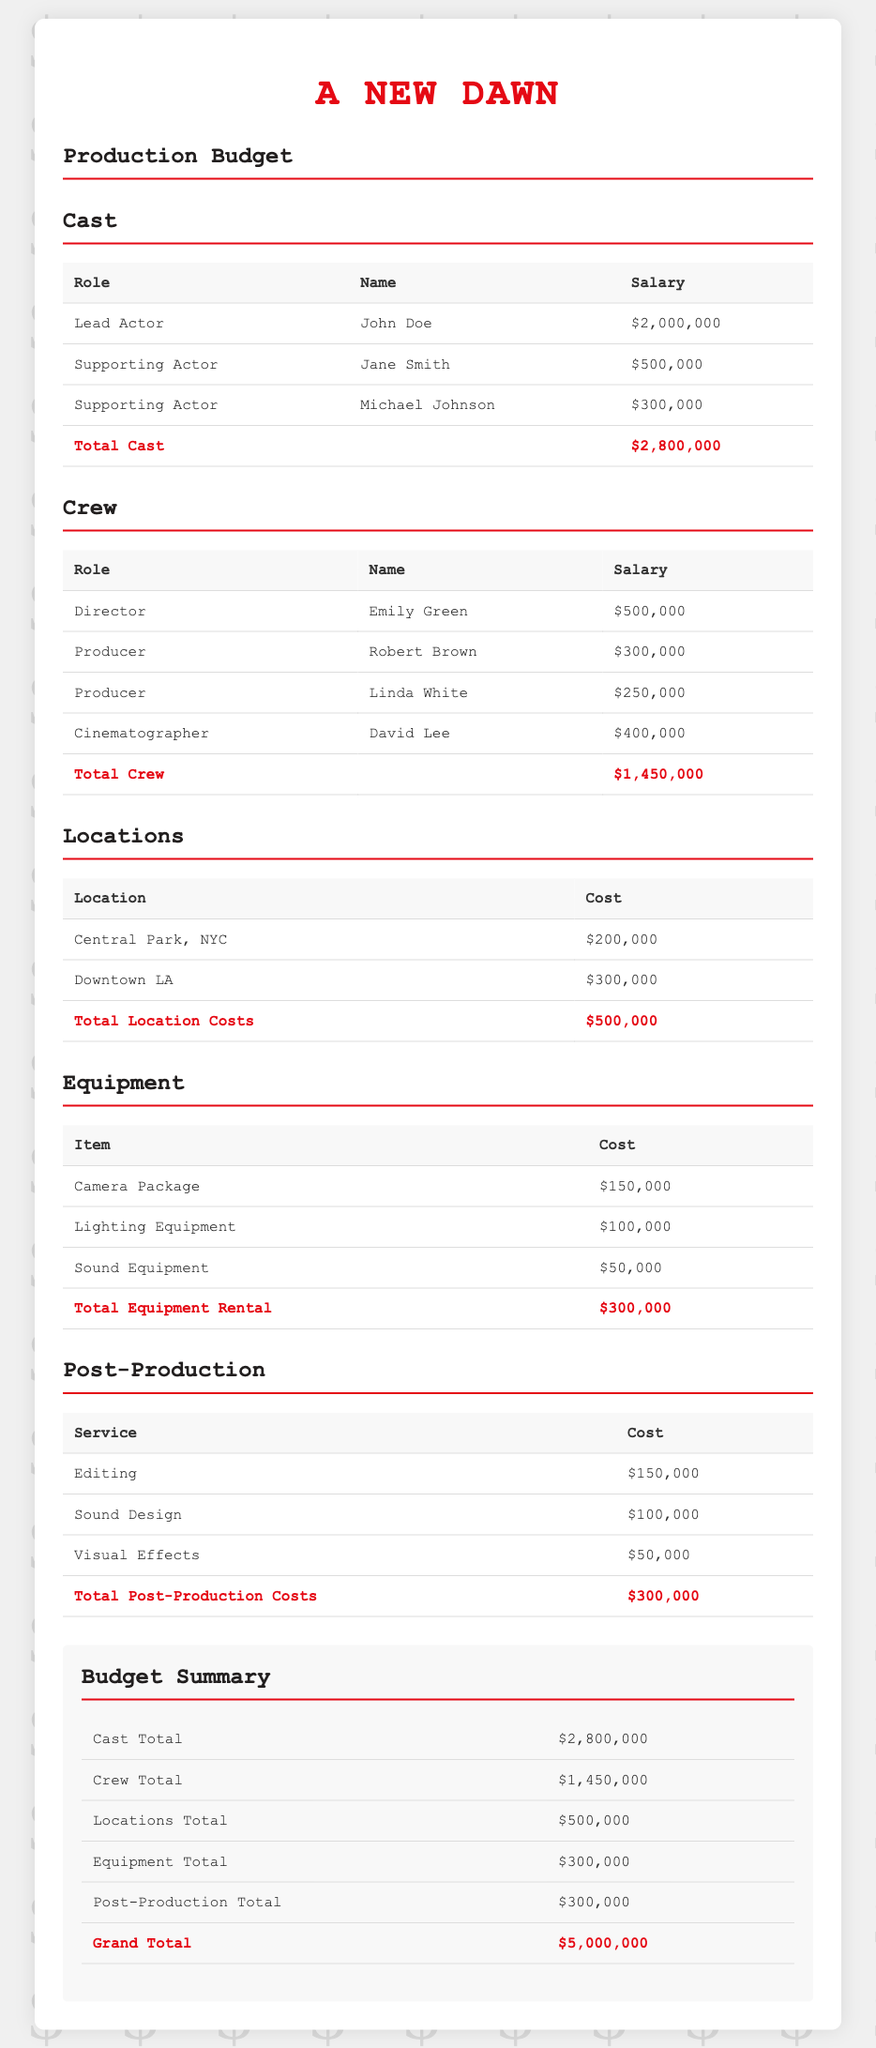What is the total salary of the lead actor? The lead actor's salary is explicitly stated in the document as $2,000,000.
Answer: $2,000,000 What is the total crew cost? The total crew cost is summated from individual salaries listed, which totals $1,450,000.
Answer: $1,450,000 How much was spent on locations? The total cost for locations is provided in the locations section as $500,000.
Answer: $500,000 What is the cost of the camera package? The document specifies that the cost of the camera package is $150,000.
Answer: $150,000 What is the total post-production cost? The total for post-production is calculated in the document as $300,000.
Answer: $300,000 Who is the director? The document lists Emily Green as the director, which answers this question.
Answer: Emily Green What is the grand total of the production budget? The grand total is calculated from all sections and stated as $5,000,000.
Answer: $5,000,000 What is the salary of the supporting actor, Michael Johnson? The specific salary for Michael Johnson as a supporting actor is noted as $300,000.
Answer: $300,000 How many producers are listed? The document mentions two distinct producers, Robert Brown and Linda White.
Answer: 2 